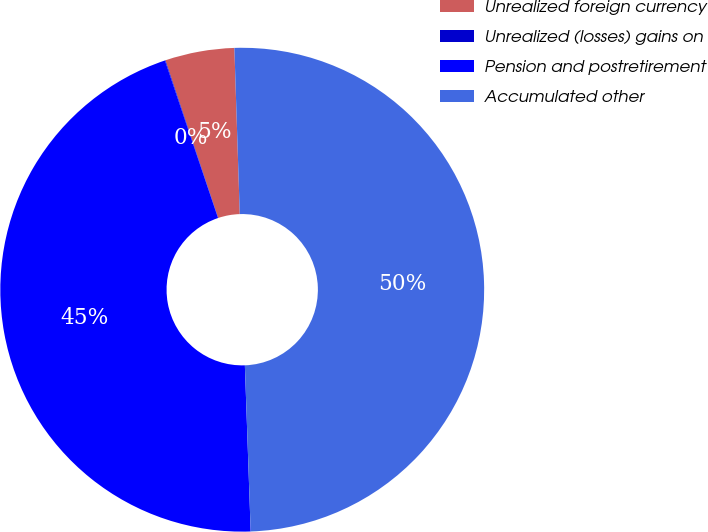Convert chart to OTSL. <chart><loc_0><loc_0><loc_500><loc_500><pie_chart><fcel>Unrealized foreign currency<fcel>Unrealized (losses) gains on<fcel>Pension and postretirement<fcel>Accumulated other<nl><fcel>4.62%<fcel>0.04%<fcel>45.38%<fcel>49.96%<nl></chart> 